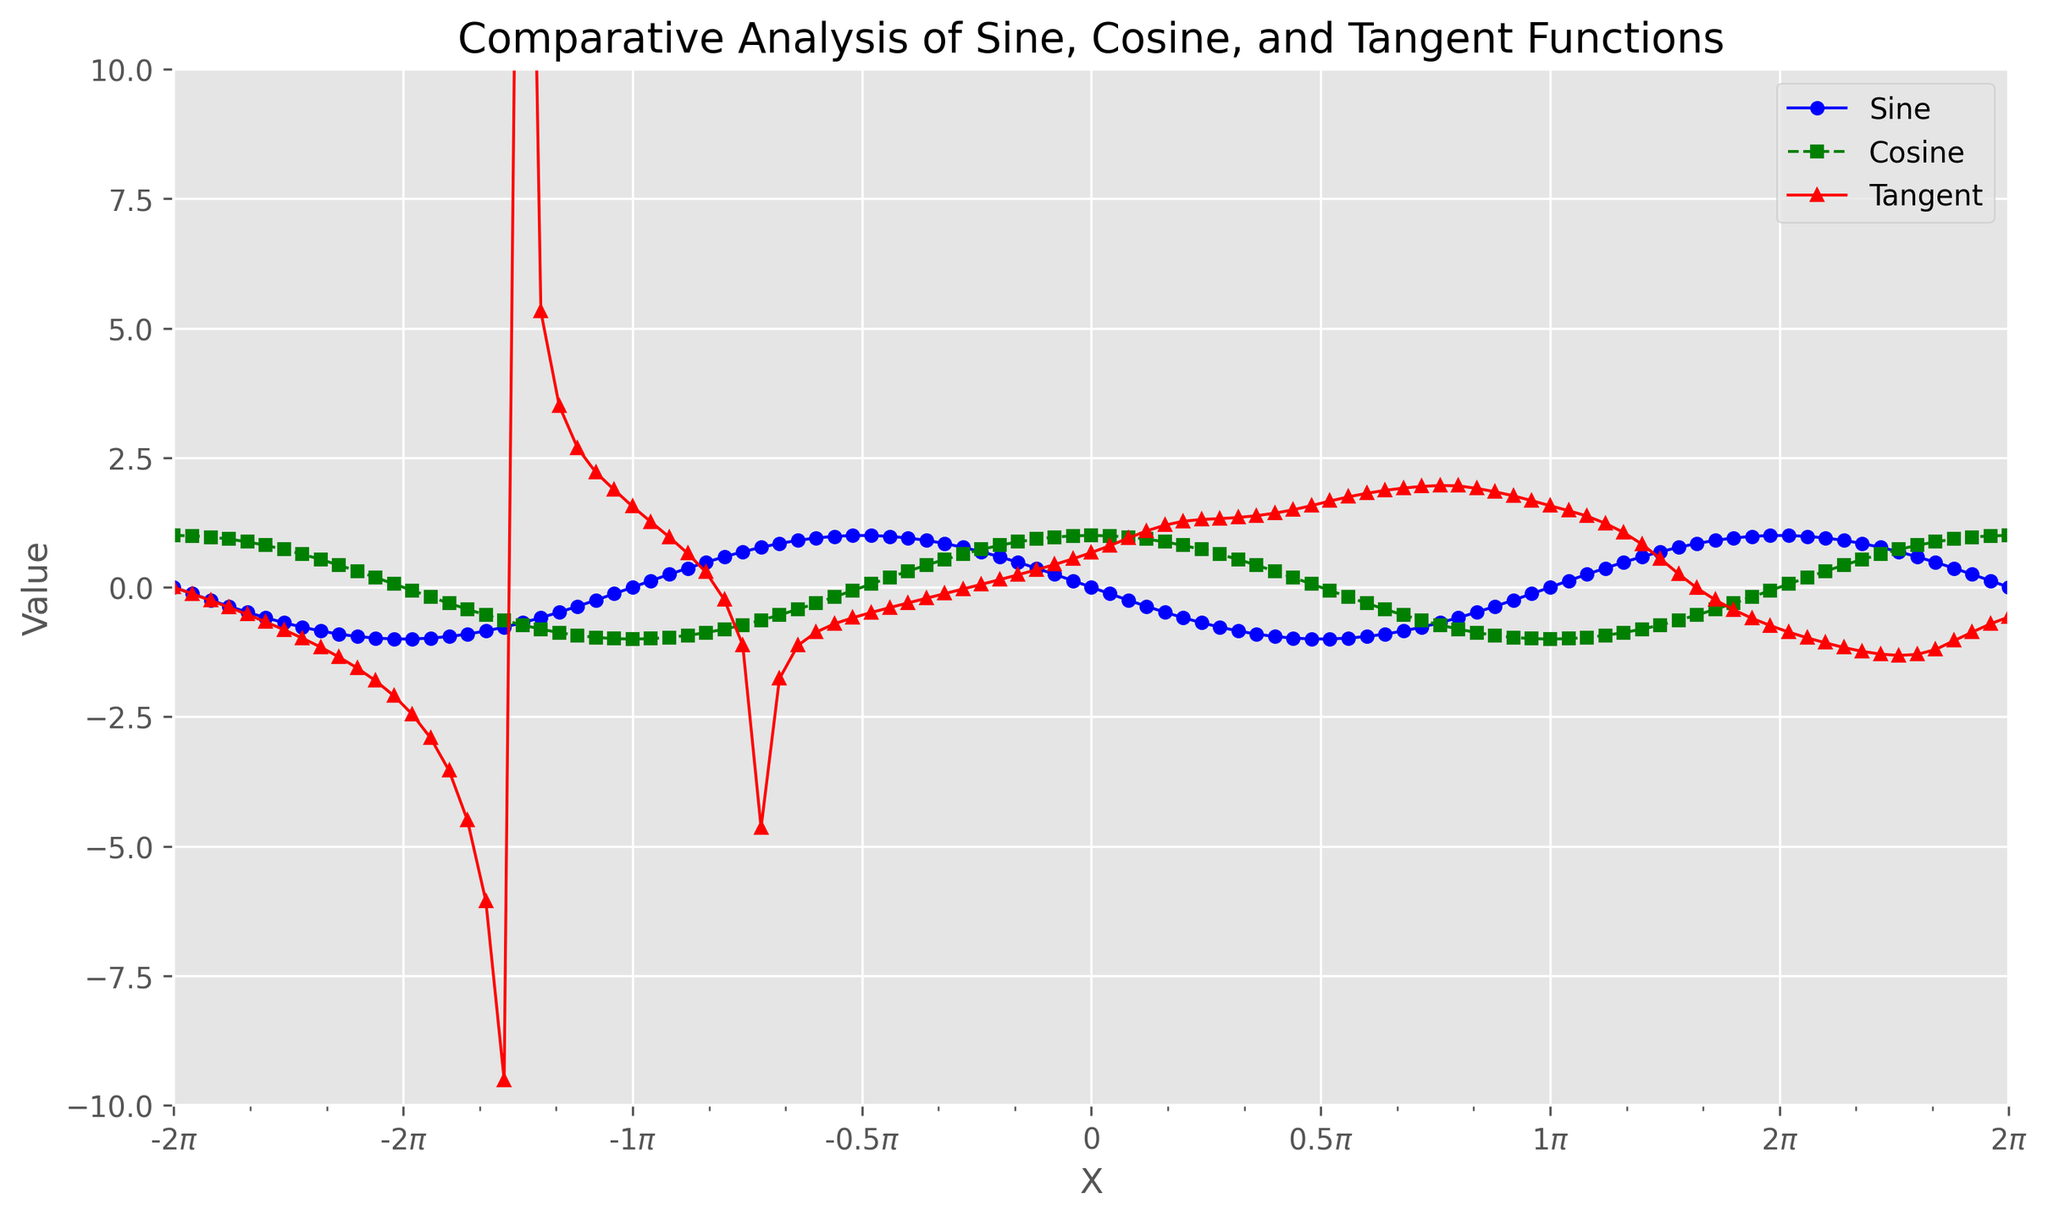Q1: Which function has the highest amplitude? Amplitude refers to the peak value of the function. By looking at the y-axis, we see that the tangent function reaches values as high as ±10, while sine and cosine reach approximately ±1. Thus, the tangent function has the highest amplitude.
Answer: Tangent Q2: At what x-value do sine and cosine first reach their maximum values within the shown range? The maximum value for sine and cosine is 1. From the plot, both sine and cosine reach 1 at x = 0 within the shown range.
Answer: 0 Q3: How often does the sine function complete one full cycle within the given x-range? One full cycle of the sine function is its period, which is 2π. By analyzing the x-axis from -2π to 2π, we can see that the sine function completes exactly two full cycles.
Answer: 2 cycles Q4: Which function has more frequent oscillations: sine or cosine? Since sine and cosine functions both have the same period of 2π, each function oscillates with the same frequency.
Answer: Neither (Both are equal) Q5: At what points do the sine and cosine functions intersect within the given range? Intersections occur where the sine and cosine values are equal. The plot shows intersections at multiple points within the range, specifically at x = -π/4, π/4, 3π/4, -3π/4, and so on.
Answer: -π/4, π/4, -3π/4, 3π/4 Q6: How does the amplitude of the sine function compare to that of the cosine function? Both sine and cosine function have the same amplitude, which is 1, as indicated by the peaks and troughs reaching 1 and -1, respectively.
Answer: Equal Q7: Between which two functions is the phase shift most pronounced? The phase shift refers to a horizontal shift between functions. By comparing sine, cosine, and tangent on the plot, the phase shift between sine and cosine is most pronounced since they are shifted by π/2 relative to each other.
Answer: Sine and Cosine Q8: Where does the tangent function approach infinity within the given x-range? The tangent function approaches infinity at its vertical asymptotes, which are at odd multiples of π/2, i.e., ±π/2, ±3π/2,... within the range shown on the plot.
Answer: ±π/2, ±3π/2 Q9: During which interval does the cosine function have negative values? By examining the cosine wave, it becomes negative between x = π/2 and x = 3π/2, and similarly between x = -π/2 and x = -3π/2.
Answer: π/2 to 3π/2 and -π/2 to -3π/2 Q10: Which points on the x-axis correspond to the zero crossings of the sine function? Zero crossings for the sine function occur where the sine value equals zero. From the plot, these occur at integer multiples of π, i.e., x = -2π, -π, 0, π, 2π.
Answer: -2π, -π, 0, π, 2π 